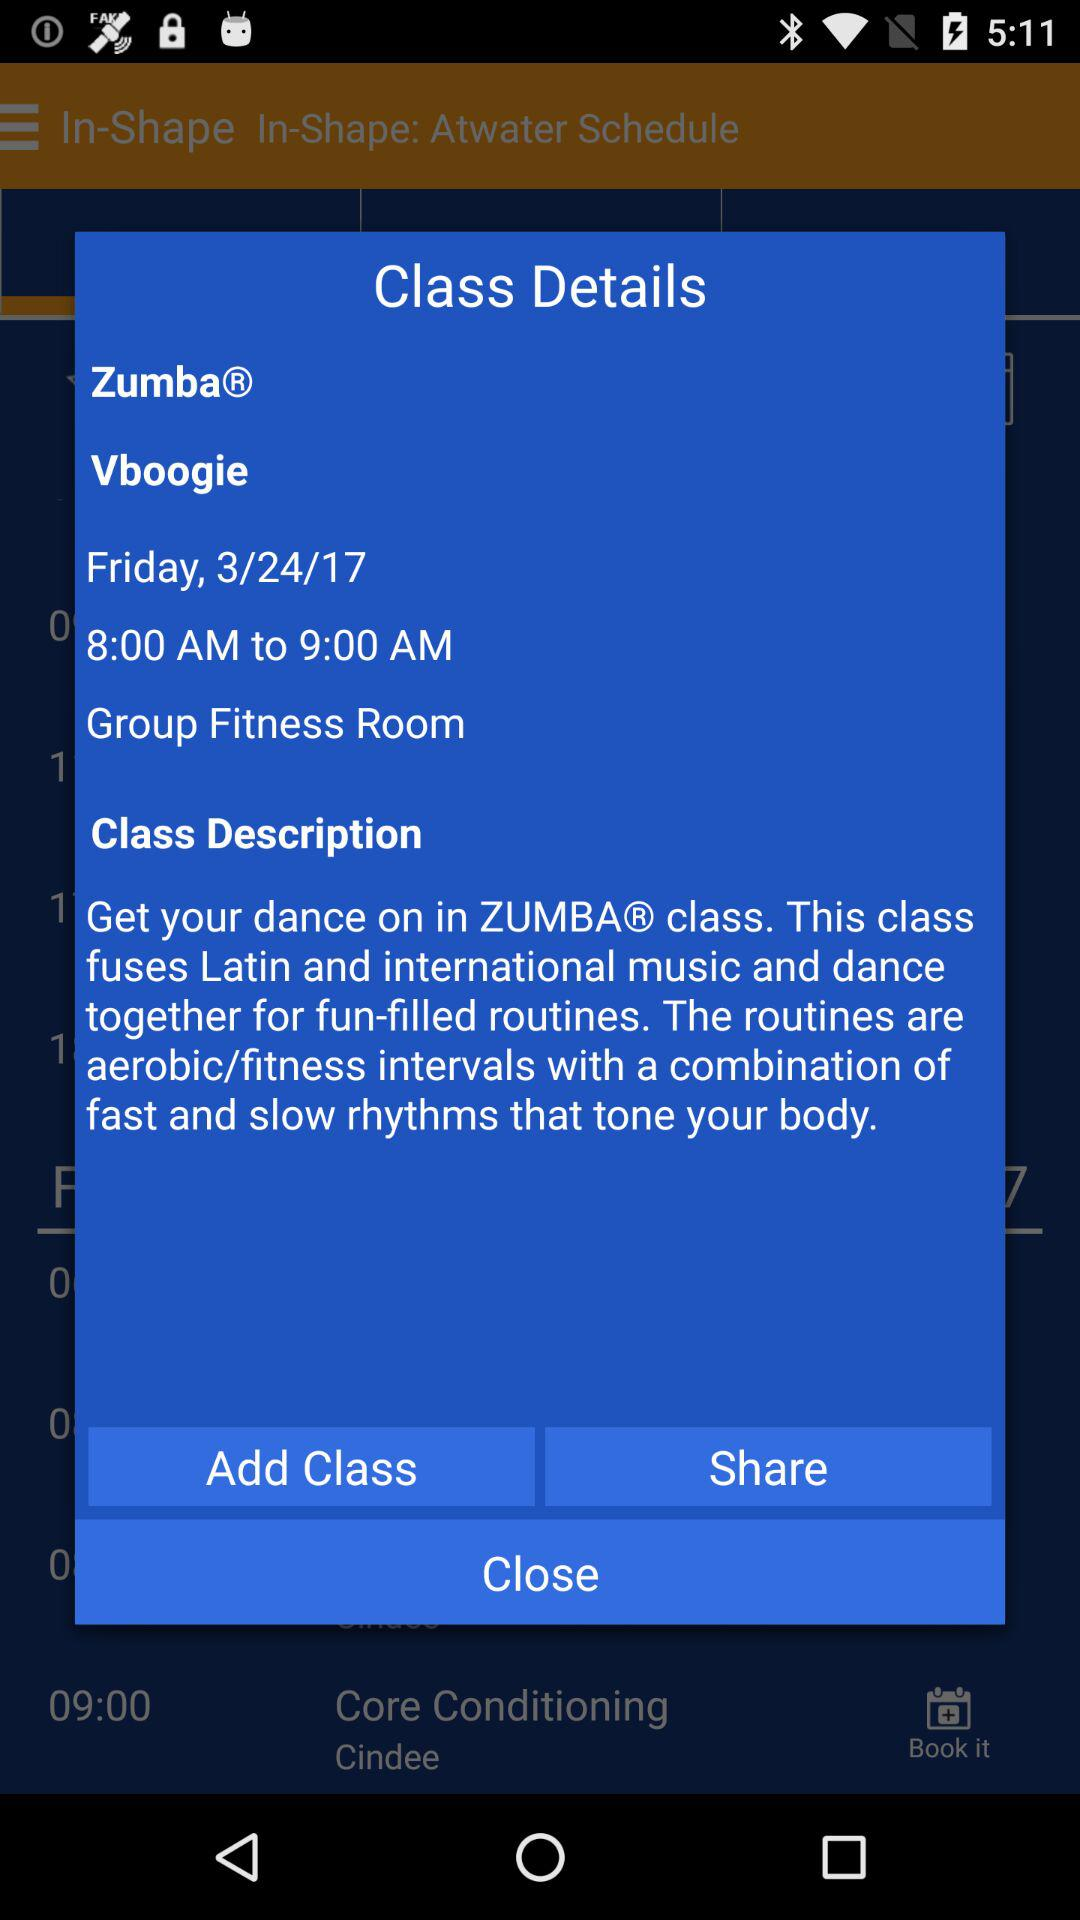What is the date? The date is Friday, 3/24/17. 